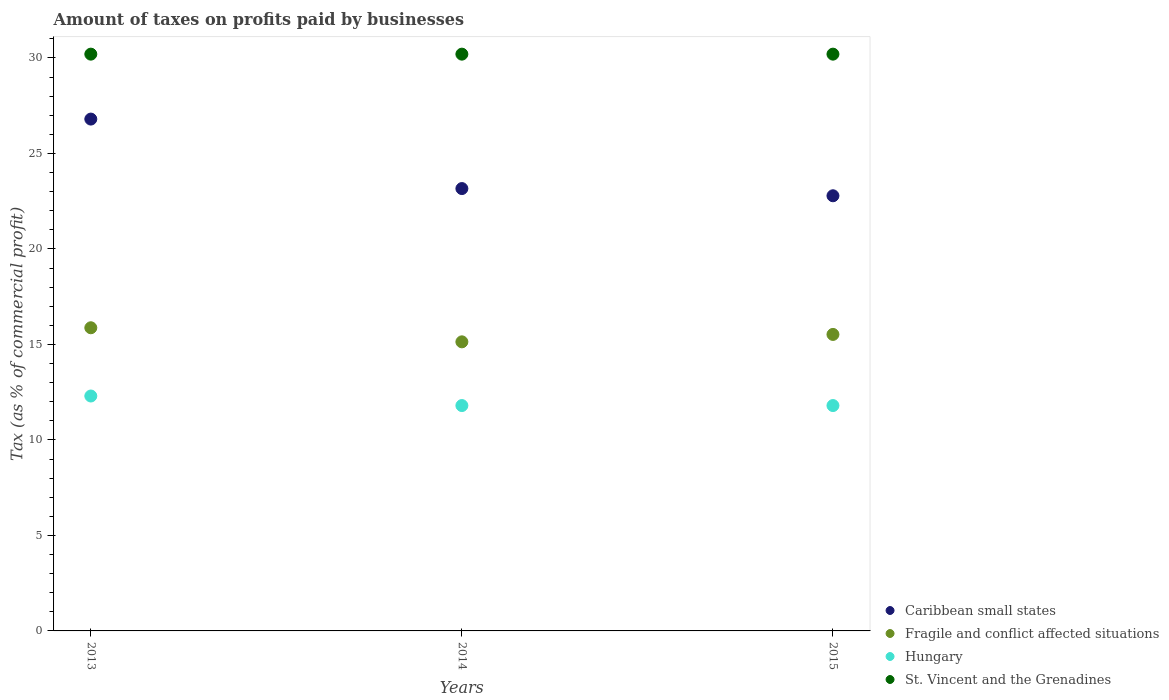Is the number of dotlines equal to the number of legend labels?
Your response must be concise. Yes. What is the percentage of taxes paid by businesses in Caribbean small states in 2014?
Your response must be concise. 23.16. Across all years, what is the maximum percentage of taxes paid by businesses in St. Vincent and the Grenadines?
Offer a terse response. 30.2. Across all years, what is the minimum percentage of taxes paid by businesses in Hungary?
Give a very brief answer. 11.8. In which year was the percentage of taxes paid by businesses in Caribbean small states minimum?
Offer a terse response. 2015. What is the total percentage of taxes paid by businesses in Fragile and conflict affected situations in the graph?
Your answer should be very brief. 46.53. What is the difference between the percentage of taxes paid by businesses in Caribbean small states in 2013 and that in 2015?
Offer a very short reply. 4.02. What is the difference between the percentage of taxes paid by businesses in Fragile and conflict affected situations in 2015 and the percentage of taxes paid by businesses in St. Vincent and the Grenadines in 2014?
Your response must be concise. -14.68. What is the average percentage of taxes paid by businesses in St. Vincent and the Grenadines per year?
Keep it short and to the point. 30.2. In the year 2013, what is the difference between the percentage of taxes paid by businesses in Fragile and conflict affected situations and percentage of taxes paid by businesses in St. Vincent and the Grenadines?
Keep it short and to the point. -14.33. What is the ratio of the percentage of taxes paid by businesses in Caribbean small states in 2014 to that in 2015?
Give a very brief answer. 1.02. Is the percentage of taxes paid by businesses in Caribbean small states in 2013 less than that in 2015?
Provide a short and direct response. No. Is the sum of the percentage of taxes paid by businesses in Caribbean small states in 2014 and 2015 greater than the maximum percentage of taxes paid by businesses in Hungary across all years?
Offer a terse response. Yes. Is it the case that in every year, the sum of the percentage of taxes paid by businesses in Hungary and percentage of taxes paid by businesses in Fragile and conflict affected situations  is greater than the sum of percentage of taxes paid by businesses in St. Vincent and the Grenadines and percentage of taxes paid by businesses in Caribbean small states?
Provide a short and direct response. No. Is it the case that in every year, the sum of the percentage of taxes paid by businesses in Fragile and conflict affected situations and percentage of taxes paid by businesses in Hungary  is greater than the percentage of taxes paid by businesses in Caribbean small states?
Your answer should be compact. Yes. How many dotlines are there?
Ensure brevity in your answer.  4. What is the difference between two consecutive major ticks on the Y-axis?
Keep it short and to the point. 5. Are the values on the major ticks of Y-axis written in scientific E-notation?
Offer a very short reply. No. Does the graph contain any zero values?
Provide a succinct answer. No. What is the title of the graph?
Provide a short and direct response. Amount of taxes on profits paid by businesses. What is the label or title of the Y-axis?
Your answer should be compact. Tax (as % of commercial profit). What is the Tax (as % of commercial profit) of Caribbean small states in 2013?
Make the answer very short. 26.8. What is the Tax (as % of commercial profit) of Fragile and conflict affected situations in 2013?
Your answer should be very brief. 15.87. What is the Tax (as % of commercial profit) in St. Vincent and the Grenadines in 2013?
Your answer should be very brief. 30.2. What is the Tax (as % of commercial profit) in Caribbean small states in 2014?
Your answer should be compact. 23.16. What is the Tax (as % of commercial profit) of Fragile and conflict affected situations in 2014?
Your response must be concise. 15.14. What is the Tax (as % of commercial profit) of Hungary in 2014?
Provide a short and direct response. 11.8. What is the Tax (as % of commercial profit) in St. Vincent and the Grenadines in 2014?
Ensure brevity in your answer.  30.2. What is the Tax (as % of commercial profit) in Caribbean small states in 2015?
Provide a succinct answer. 22.78. What is the Tax (as % of commercial profit) of Fragile and conflict affected situations in 2015?
Keep it short and to the point. 15.52. What is the Tax (as % of commercial profit) of Hungary in 2015?
Make the answer very short. 11.8. What is the Tax (as % of commercial profit) in St. Vincent and the Grenadines in 2015?
Offer a terse response. 30.2. Across all years, what is the maximum Tax (as % of commercial profit) in Caribbean small states?
Make the answer very short. 26.8. Across all years, what is the maximum Tax (as % of commercial profit) in Fragile and conflict affected situations?
Offer a terse response. 15.87. Across all years, what is the maximum Tax (as % of commercial profit) of St. Vincent and the Grenadines?
Offer a terse response. 30.2. Across all years, what is the minimum Tax (as % of commercial profit) of Caribbean small states?
Provide a succinct answer. 22.78. Across all years, what is the minimum Tax (as % of commercial profit) in Fragile and conflict affected situations?
Provide a short and direct response. 15.14. Across all years, what is the minimum Tax (as % of commercial profit) in St. Vincent and the Grenadines?
Ensure brevity in your answer.  30.2. What is the total Tax (as % of commercial profit) in Caribbean small states in the graph?
Give a very brief answer. 72.75. What is the total Tax (as % of commercial profit) of Fragile and conflict affected situations in the graph?
Ensure brevity in your answer.  46.53. What is the total Tax (as % of commercial profit) in Hungary in the graph?
Provide a succinct answer. 35.9. What is the total Tax (as % of commercial profit) of St. Vincent and the Grenadines in the graph?
Provide a short and direct response. 90.6. What is the difference between the Tax (as % of commercial profit) in Caribbean small states in 2013 and that in 2014?
Make the answer very short. 3.64. What is the difference between the Tax (as % of commercial profit) in Fragile and conflict affected situations in 2013 and that in 2014?
Make the answer very short. 0.74. What is the difference between the Tax (as % of commercial profit) in Hungary in 2013 and that in 2014?
Give a very brief answer. 0.5. What is the difference between the Tax (as % of commercial profit) in Caribbean small states in 2013 and that in 2015?
Give a very brief answer. 4.02. What is the difference between the Tax (as % of commercial profit) in Fragile and conflict affected situations in 2013 and that in 2015?
Offer a very short reply. 0.35. What is the difference between the Tax (as % of commercial profit) of Hungary in 2013 and that in 2015?
Ensure brevity in your answer.  0.5. What is the difference between the Tax (as % of commercial profit) in Caribbean small states in 2014 and that in 2015?
Provide a short and direct response. 0.38. What is the difference between the Tax (as % of commercial profit) of Fragile and conflict affected situations in 2014 and that in 2015?
Provide a short and direct response. -0.39. What is the difference between the Tax (as % of commercial profit) in St. Vincent and the Grenadines in 2014 and that in 2015?
Keep it short and to the point. 0. What is the difference between the Tax (as % of commercial profit) of Caribbean small states in 2013 and the Tax (as % of commercial profit) of Fragile and conflict affected situations in 2014?
Keep it short and to the point. 11.66. What is the difference between the Tax (as % of commercial profit) of Fragile and conflict affected situations in 2013 and the Tax (as % of commercial profit) of Hungary in 2014?
Keep it short and to the point. 4.07. What is the difference between the Tax (as % of commercial profit) of Fragile and conflict affected situations in 2013 and the Tax (as % of commercial profit) of St. Vincent and the Grenadines in 2014?
Your response must be concise. -14.33. What is the difference between the Tax (as % of commercial profit) in Hungary in 2013 and the Tax (as % of commercial profit) in St. Vincent and the Grenadines in 2014?
Your answer should be very brief. -17.9. What is the difference between the Tax (as % of commercial profit) in Caribbean small states in 2013 and the Tax (as % of commercial profit) in Fragile and conflict affected situations in 2015?
Offer a terse response. 11.28. What is the difference between the Tax (as % of commercial profit) in Caribbean small states in 2013 and the Tax (as % of commercial profit) in Hungary in 2015?
Your response must be concise. 15. What is the difference between the Tax (as % of commercial profit) in Fragile and conflict affected situations in 2013 and the Tax (as % of commercial profit) in Hungary in 2015?
Provide a short and direct response. 4.07. What is the difference between the Tax (as % of commercial profit) in Fragile and conflict affected situations in 2013 and the Tax (as % of commercial profit) in St. Vincent and the Grenadines in 2015?
Your response must be concise. -14.33. What is the difference between the Tax (as % of commercial profit) of Hungary in 2013 and the Tax (as % of commercial profit) of St. Vincent and the Grenadines in 2015?
Ensure brevity in your answer.  -17.9. What is the difference between the Tax (as % of commercial profit) of Caribbean small states in 2014 and the Tax (as % of commercial profit) of Fragile and conflict affected situations in 2015?
Make the answer very short. 7.64. What is the difference between the Tax (as % of commercial profit) in Caribbean small states in 2014 and the Tax (as % of commercial profit) in Hungary in 2015?
Give a very brief answer. 11.36. What is the difference between the Tax (as % of commercial profit) in Caribbean small states in 2014 and the Tax (as % of commercial profit) in St. Vincent and the Grenadines in 2015?
Give a very brief answer. -7.04. What is the difference between the Tax (as % of commercial profit) of Fragile and conflict affected situations in 2014 and the Tax (as % of commercial profit) of Hungary in 2015?
Offer a terse response. 3.34. What is the difference between the Tax (as % of commercial profit) of Fragile and conflict affected situations in 2014 and the Tax (as % of commercial profit) of St. Vincent and the Grenadines in 2015?
Give a very brief answer. -15.06. What is the difference between the Tax (as % of commercial profit) of Hungary in 2014 and the Tax (as % of commercial profit) of St. Vincent and the Grenadines in 2015?
Provide a short and direct response. -18.4. What is the average Tax (as % of commercial profit) in Caribbean small states per year?
Your answer should be very brief. 24.25. What is the average Tax (as % of commercial profit) of Fragile and conflict affected situations per year?
Offer a very short reply. 15.51. What is the average Tax (as % of commercial profit) in Hungary per year?
Offer a terse response. 11.97. What is the average Tax (as % of commercial profit) in St. Vincent and the Grenadines per year?
Provide a succinct answer. 30.2. In the year 2013, what is the difference between the Tax (as % of commercial profit) in Caribbean small states and Tax (as % of commercial profit) in Fragile and conflict affected situations?
Provide a short and direct response. 10.93. In the year 2013, what is the difference between the Tax (as % of commercial profit) in Caribbean small states and Tax (as % of commercial profit) in Hungary?
Ensure brevity in your answer.  14.5. In the year 2013, what is the difference between the Tax (as % of commercial profit) of Caribbean small states and Tax (as % of commercial profit) of St. Vincent and the Grenadines?
Your answer should be compact. -3.4. In the year 2013, what is the difference between the Tax (as % of commercial profit) in Fragile and conflict affected situations and Tax (as % of commercial profit) in Hungary?
Give a very brief answer. 3.57. In the year 2013, what is the difference between the Tax (as % of commercial profit) in Fragile and conflict affected situations and Tax (as % of commercial profit) in St. Vincent and the Grenadines?
Your response must be concise. -14.33. In the year 2013, what is the difference between the Tax (as % of commercial profit) in Hungary and Tax (as % of commercial profit) in St. Vincent and the Grenadines?
Provide a succinct answer. -17.9. In the year 2014, what is the difference between the Tax (as % of commercial profit) in Caribbean small states and Tax (as % of commercial profit) in Fragile and conflict affected situations?
Offer a terse response. 8.03. In the year 2014, what is the difference between the Tax (as % of commercial profit) in Caribbean small states and Tax (as % of commercial profit) in Hungary?
Provide a short and direct response. 11.36. In the year 2014, what is the difference between the Tax (as % of commercial profit) of Caribbean small states and Tax (as % of commercial profit) of St. Vincent and the Grenadines?
Give a very brief answer. -7.04. In the year 2014, what is the difference between the Tax (as % of commercial profit) of Fragile and conflict affected situations and Tax (as % of commercial profit) of Hungary?
Your answer should be very brief. 3.34. In the year 2014, what is the difference between the Tax (as % of commercial profit) in Fragile and conflict affected situations and Tax (as % of commercial profit) in St. Vincent and the Grenadines?
Ensure brevity in your answer.  -15.06. In the year 2014, what is the difference between the Tax (as % of commercial profit) of Hungary and Tax (as % of commercial profit) of St. Vincent and the Grenadines?
Provide a succinct answer. -18.4. In the year 2015, what is the difference between the Tax (as % of commercial profit) of Caribbean small states and Tax (as % of commercial profit) of Fragile and conflict affected situations?
Provide a short and direct response. 7.26. In the year 2015, what is the difference between the Tax (as % of commercial profit) of Caribbean small states and Tax (as % of commercial profit) of Hungary?
Your response must be concise. 10.98. In the year 2015, what is the difference between the Tax (as % of commercial profit) in Caribbean small states and Tax (as % of commercial profit) in St. Vincent and the Grenadines?
Provide a short and direct response. -7.42. In the year 2015, what is the difference between the Tax (as % of commercial profit) of Fragile and conflict affected situations and Tax (as % of commercial profit) of Hungary?
Give a very brief answer. 3.72. In the year 2015, what is the difference between the Tax (as % of commercial profit) in Fragile and conflict affected situations and Tax (as % of commercial profit) in St. Vincent and the Grenadines?
Ensure brevity in your answer.  -14.68. In the year 2015, what is the difference between the Tax (as % of commercial profit) of Hungary and Tax (as % of commercial profit) of St. Vincent and the Grenadines?
Give a very brief answer. -18.4. What is the ratio of the Tax (as % of commercial profit) of Caribbean small states in 2013 to that in 2014?
Provide a short and direct response. 1.16. What is the ratio of the Tax (as % of commercial profit) in Fragile and conflict affected situations in 2013 to that in 2014?
Keep it short and to the point. 1.05. What is the ratio of the Tax (as % of commercial profit) of Hungary in 2013 to that in 2014?
Offer a very short reply. 1.04. What is the ratio of the Tax (as % of commercial profit) in Caribbean small states in 2013 to that in 2015?
Offer a terse response. 1.18. What is the ratio of the Tax (as % of commercial profit) of Fragile and conflict affected situations in 2013 to that in 2015?
Your answer should be compact. 1.02. What is the ratio of the Tax (as % of commercial profit) in Hungary in 2013 to that in 2015?
Your answer should be very brief. 1.04. What is the ratio of the Tax (as % of commercial profit) in Caribbean small states in 2014 to that in 2015?
Make the answer very short. 1.02. What is the ratio of the Tax (as % of commercial profit) of Fragile and conflict affected situations in 2014 to that in 2015?
Provide a succinct answer. 0.97. What is the ratio of the Tax (as % of commercial profit) of Hungary in 2014 to that in 2015?
Your response must be concise. 1. What is the ratio of the Tax (as % of commercial profit) of St. Vincent and the Grenadines in 2014 to that in 2015?
Offer a very short reply. 1. What is the difference between the highest and the second highest Tax (as % of commercial profit) of Caribbean small states?
Your response must be concise. 3.64. What is the difference between the highest and the second highest Tax (as % of commercial profit) in Fragile and conflict affected situations?
Your response must be concise. 0.35. What is the difference between the highest and the second highest Tax (as % of commercial profit) in Hungary?
Your answer should be very brief. 0.5. What is the difference between the highest and the lowest Tax (as % of commercial profit) in Caribbean small states?
Offer a very short reply. 4.02. What is the difference between the highest and the lowest Tax (as % of commercial profit) of Fragile and conflict affected situations?
Give a very brief answer. 0.74. What is the difference between the highest and the lowest Tax (as % of commercial profit) in Hungary?
Your answer should be very brief. 0.5. 